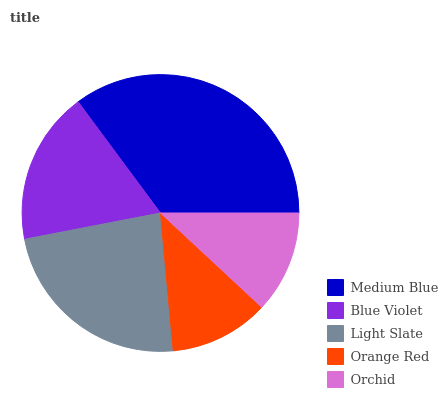Is Orange Red the minimum?
Answer yes or no. Yes. Is Medium Blue the maximum?
Answer yes or no. Yes. Is Blue Violet the minimum?
Answer yes or no. No. Is Blue Violet the maximum?
Answer yes or no. No. Is Medium Blue greater than Blue Violet?
Answer yes or no. Yes. Is Blue Violet less than Medium Blue?
Answer yes or no. Yes. Is Blue Violet greater than Medium Blue?
Answer yes or no. No. Is Medium Blue less than Blue Violet?
Answer yes or no. No. Is Blue Violet the high median?
Answer yes or no. Yes. Is Blue Violet the low median?
Answer yes or no. Yes. Is Orange Red the high median?
Answer yes or no. No. Is Light Slate the low median?
Answer yes or no. No. 